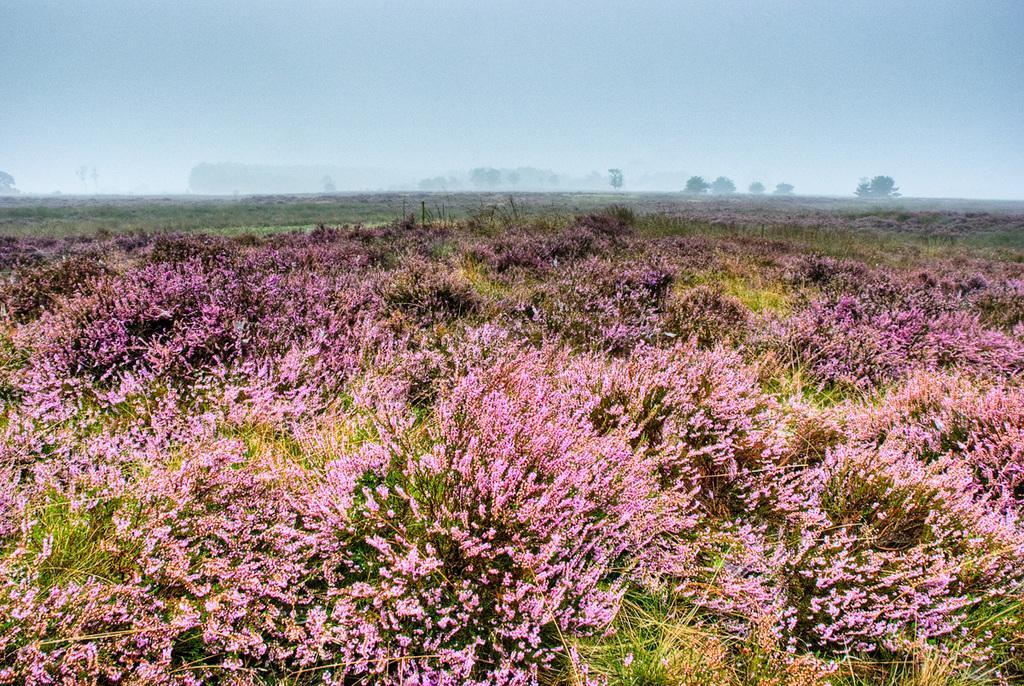Describe this image in one or two sentences. In the foreground we can see the flowers. In the background, we can see the trees. This is a sky with clouds. 